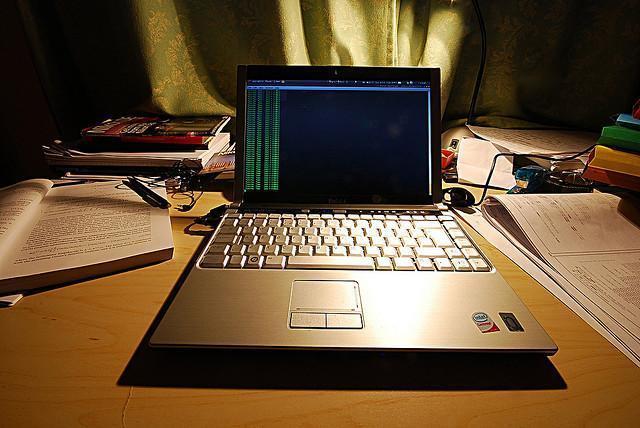How many books are there?
Give a very brief answer. 3. How many surfboards are in this picture?
Give a very brief answer. 0. 